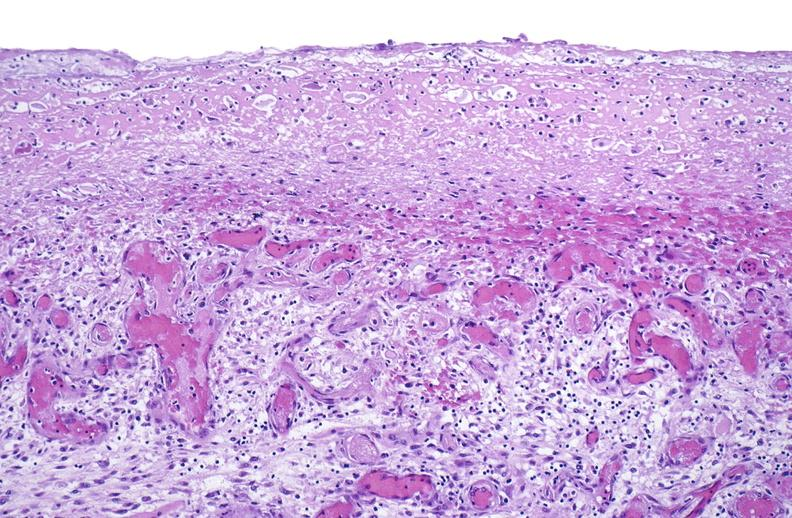does granulomata slide show tracheotomy site, granulation tissue?
Answer the question using a single word or phrase. No 